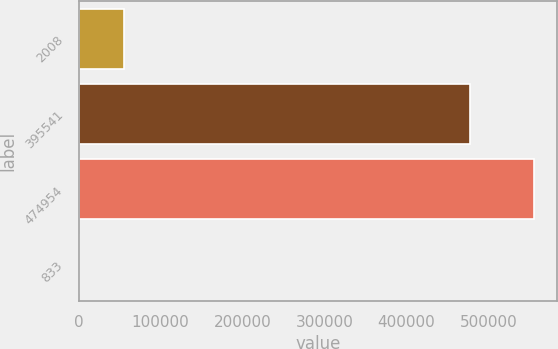Convert chart. <chart><loc_0><loc_0><loc_500><loc_500><bar_chart><fcel>2008<fcel>395541<fcel>474954<fcel>833<nl><fcel>55628.6<fcel>477007<fcel>555513<fcel>85.9<nl></chart> 